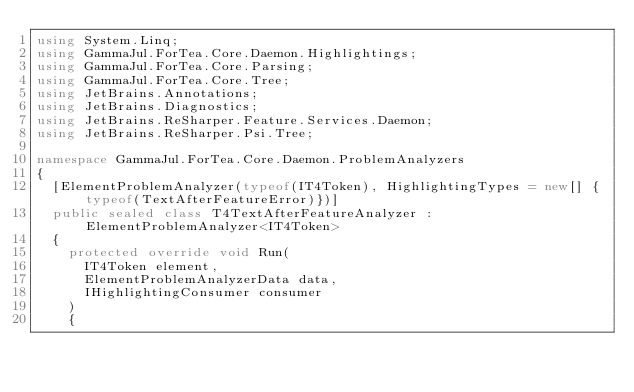Convert code to text. <code><loc_0><loc_0><loc_500><loc_500><_C#_>using System.Linq;
using GammaJul.ForTea.Core.Daemon.Highlightings;
using GammaJul.ForTea.Core.Parsing;
using GammaJul.ForTea.Core.Tree;
using JetBrains.Annotations;
using JetBrains.Diagnostics;
using JetBrains.ReSharper.Feature.Services.Daemon;
using JetBrains.ReSharper.Psi.Tree;

namespace GammaJul.ForTea.Core.Daemon.ProblemAnalyzers
{
	[ElementProblemAnalyzer(typeof(IT4Token), HighlightingTypes = new[] {typeof(TextAfterFeatureError)})]
	public sealed class T4TextAfterFeatureAnalyzer : ElementProblemAnalyzer<IT4Token>
	{
		protected override void Run(
			IT4Token element,
			ElementProblemAnalyzerData data,
			IHighlightingConsumer consumer
		)
		{</code> 